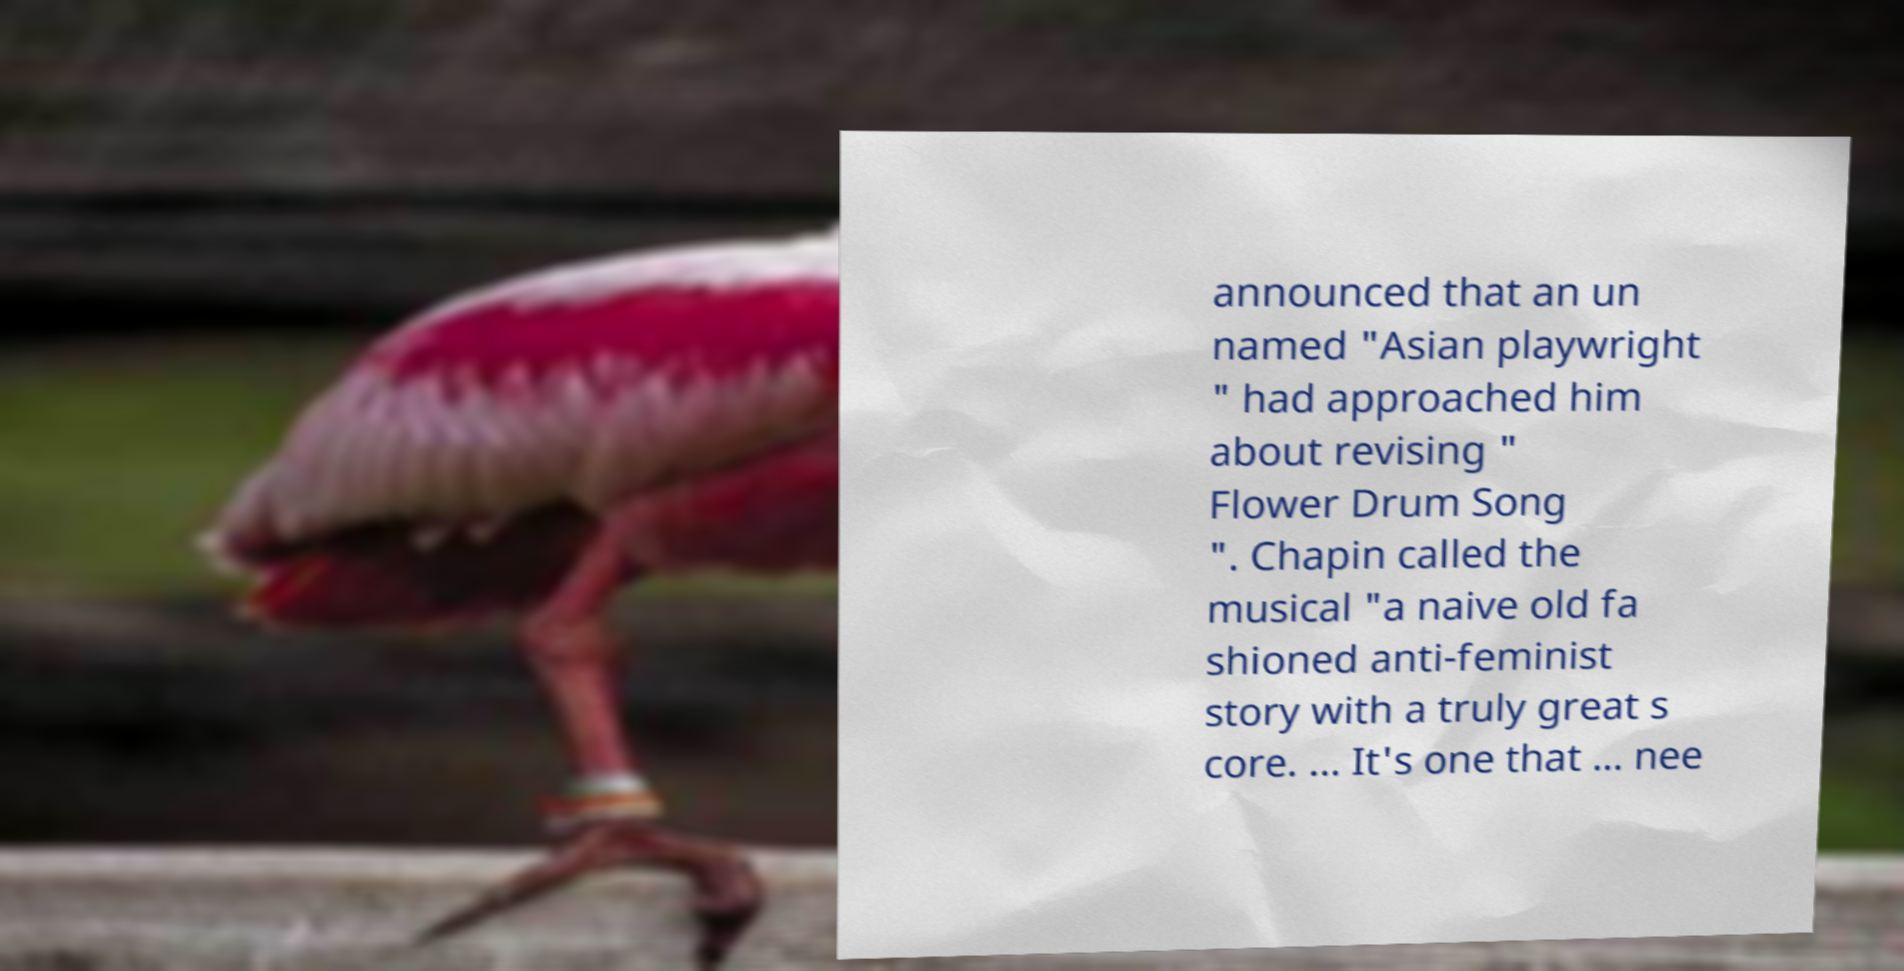What messages or text are displayed in this image? I need them in a readable, typed format. announced that an un named "Asian playwright " had approached him about revising " Flower Drum Song ". Chapin called the musical "a naive old fa shioned anti-feminist story with a truly great s core. ... It's one that ... nee 